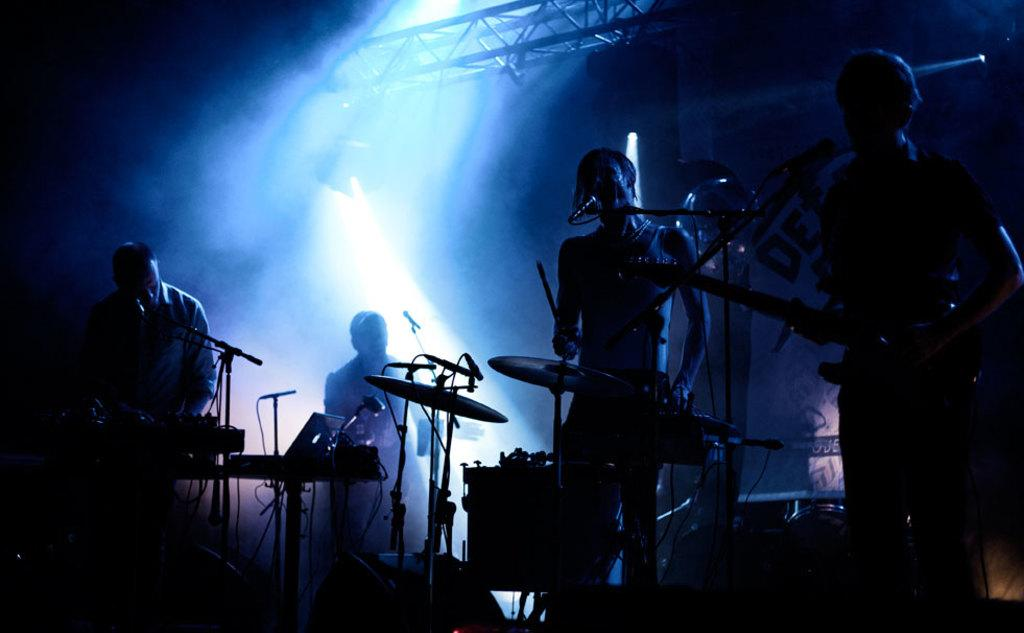How many people are in the image? There are four persons in the image. What are the persons doing in the image? The persons are playing musical instruments. What can be seen in front of the persons? The persons are standing in front of a mic. What are the persons wearing? The persons are wearing clothes. What other object is visible in the image? There is a laptop on a table in the image. What type of invention is being demonstrated by the persons in the image? There is no invention being demonstrated in the image; the persons are playing musical instruments. Can you see any birds in the image? There are no birds present in the image. 